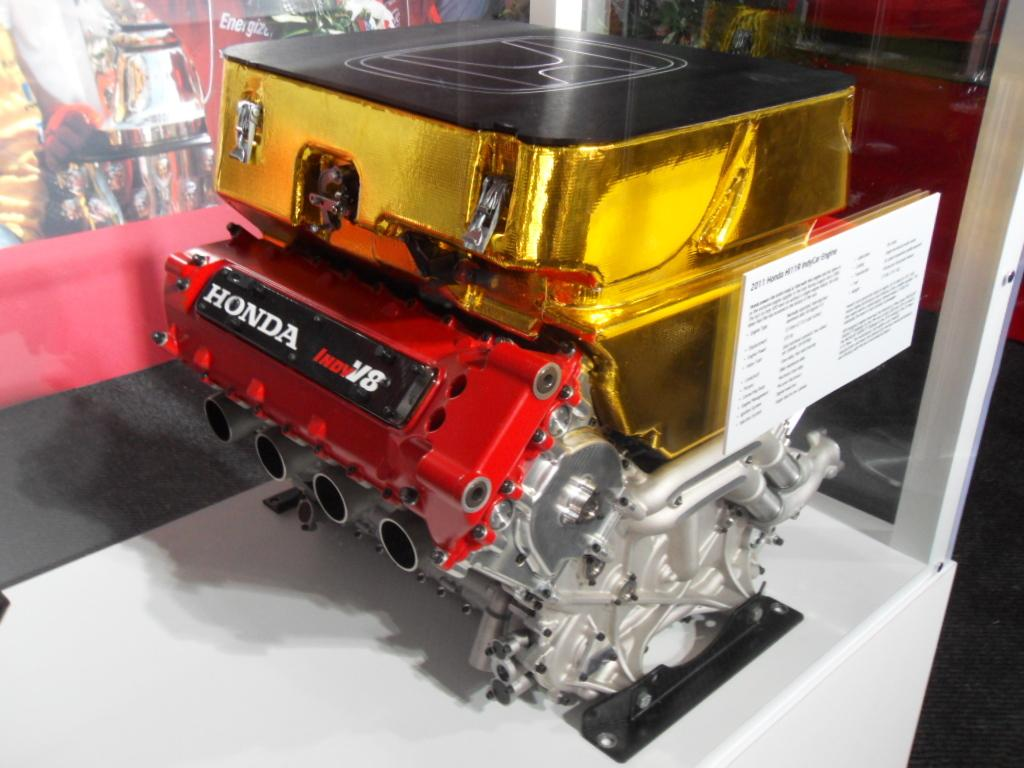What is the main subject of the image? The main subject of the image is the engine of a vehicle. What colors can be seen on the engine? The engine has red, black, white, grey, and gold colors. What is the color of the surface the engine is placed on? The engine is on a white-colored surface. Can you describe the background of the image? There are objects visible in the background of the image. How many sacks can be seen on the engine in the image? There are no sacks present on the engine in the image. What type of rings are visible on the engine in the image? There are no rings visible on the engine in the image. 